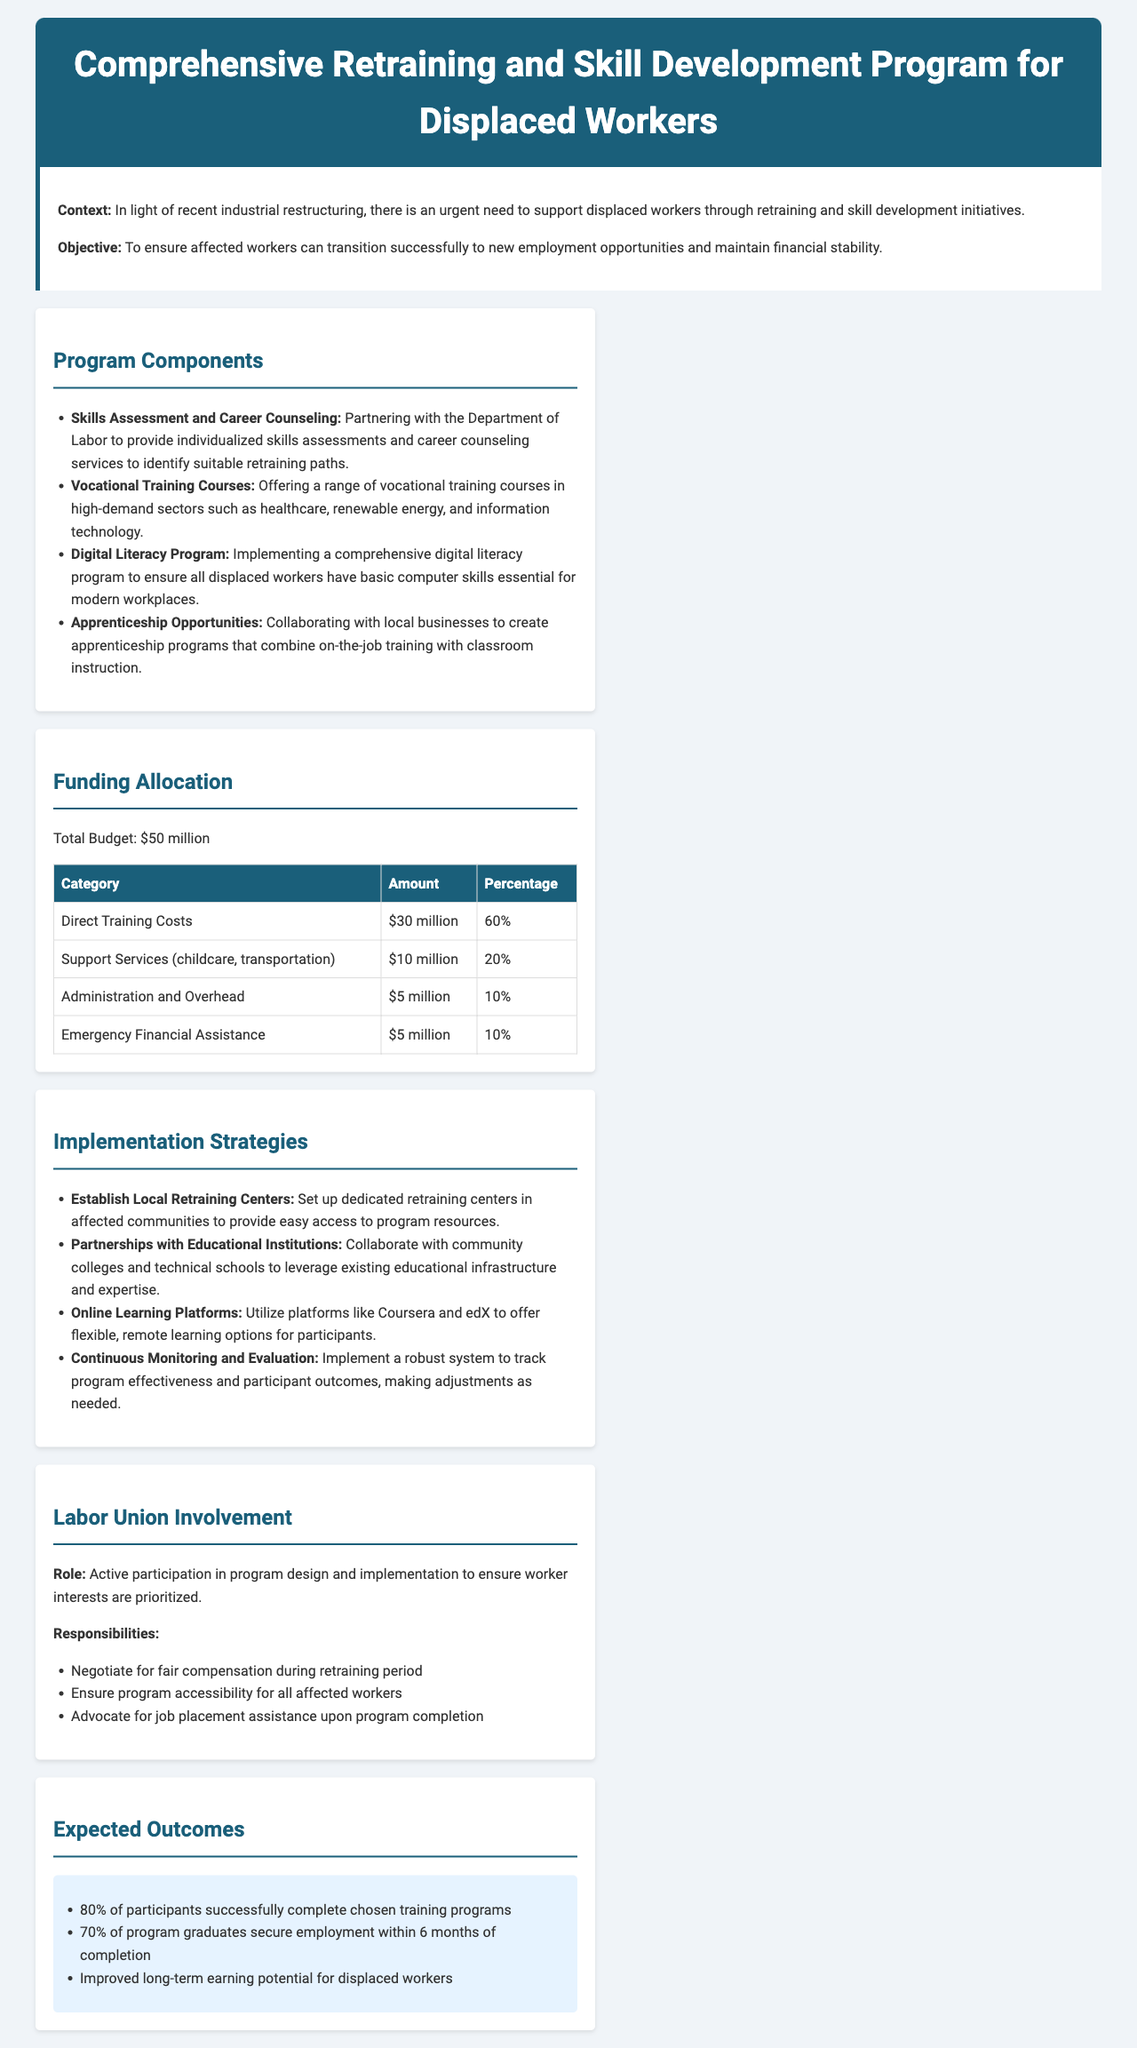What is the total budget allocated for the retraining program? The total budget is explicitly stated in the funding allocation section of the document.
Answer: $50 million What percentage of the budget is allocated for direct training costs? The budget breakdown includes specific percentages for each category, including direct training costs.
Answer: 60% Which components are included in the program? The introduction and components section outlines the different elements of the retraining program.
Answer: Skills Assessment, Vocational Training, Digital Literacy, Apprenticeship Opportunities How much funding is designated for support services? The funding allocation table provides amounts for different categories of funding, including support services.
Answer: $10 million What is one key implementation strategy mentioned in the document? The section on implementation strategies highlights various approaches to executing the program successfully.
Answer: Establish Local Retraining Centers What is the expected participant completion rate for training programs? The expected outcomes section provides metrics on the anticipated success rates of participants.
Answer: 80% Which organization is partnering for skills assessments and counseling? The document specifies partnerships for services, which includes an important governmental entity.
Answer: Department of Labor What role do labor unions play in the implementation of the program? The labor union involvement section details the responsibilities and roles that unions will take in the program.
Answer: Active participation What is the expected employment rate for program graduates within 6 months? The expected outcomes section provides specific statistics regarding job placement for graduates of the program.
Answer: 70% 